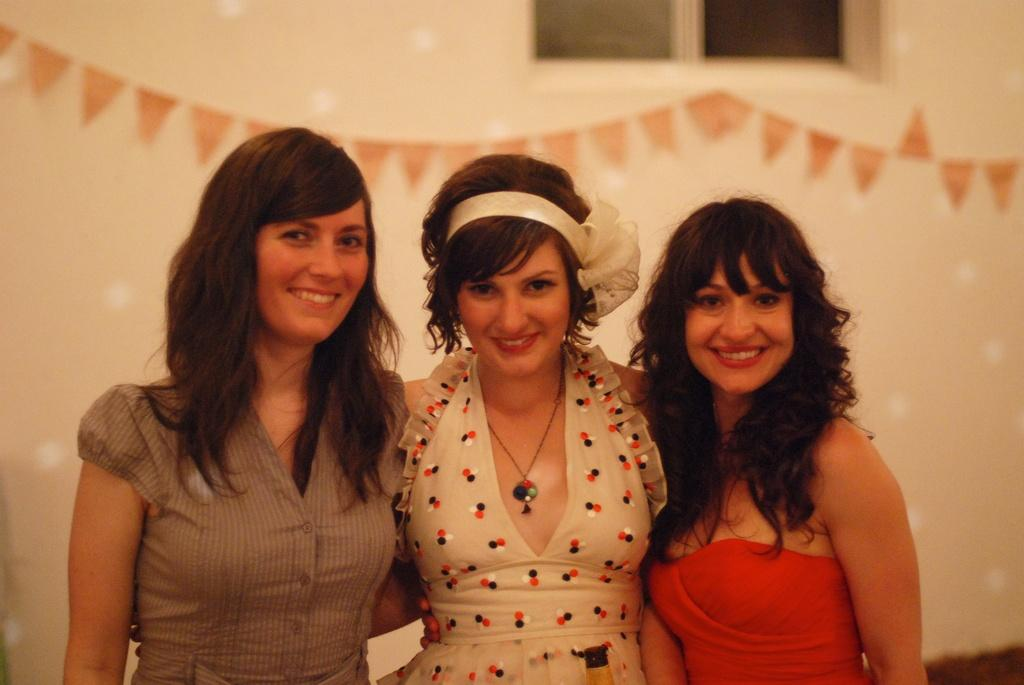How many women are in the image? There are three women in the image. What are the women doing in the image? The women are standing and smiling. What can be seen on the wall in the background? There are decorative papers on the wall in the background. What architectural feature is visible in the background? There is a window in the background. What type of kitty can be seen sitting on the notebook in the image? There is no kitty or notebook present in the image. 